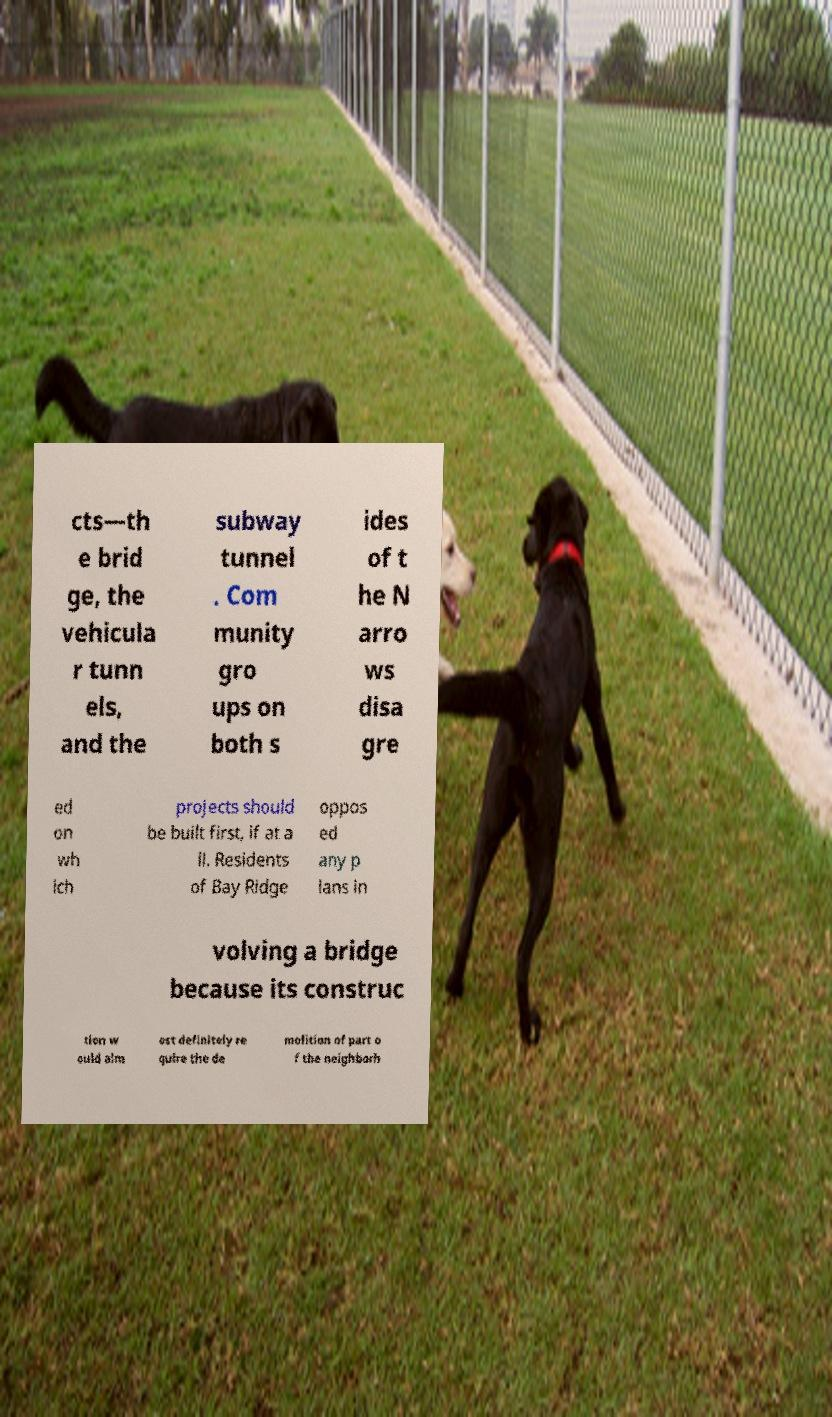For documentation purposes, I need the text within this image transcribed. Could you provide that? cts—th e brid ge, the vehicula r tunn els, and the subway tunnel . Com munity gro ups on both s ides of t he N arro ws disa gre ed on wh ich projects should be built first, if at a ll. Residents of Bay Ridge oppos ed any p lans in volving a bridge because its construc tion w ould alm ost definitely re quire the de molition of part o f the neighborh 